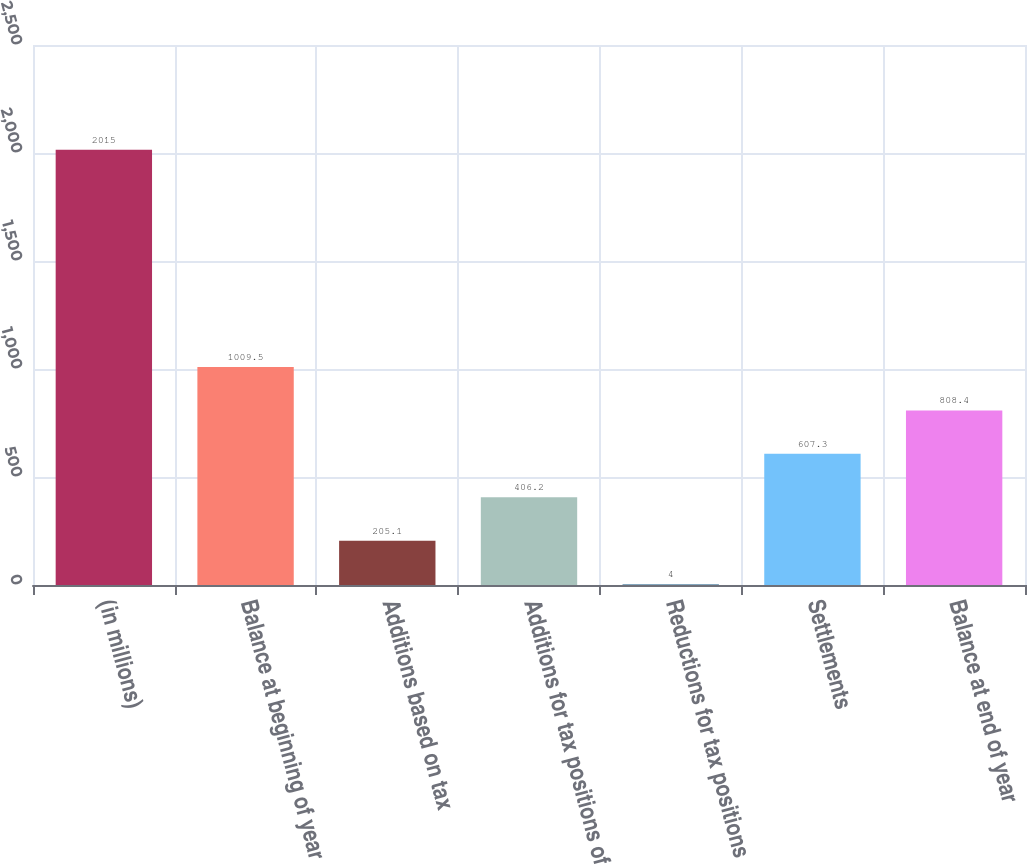<chart> <loc_0><loc_0><loc_500><loc_500><bar_chart><fcel>(in millions)<fcel>Balance at beginning of year<fcel>Additions based on tax<fcel>Additions for tax positions of<fcel>Reductions for tax positions<fcel>Settlements<fcel>Balance at end of year<nl><fcel>2015<fcel>1009.5<fcel>205.1<fcel>406.2<fcel>4<fcel>607.3<fcel>808.4<nl></chart> 